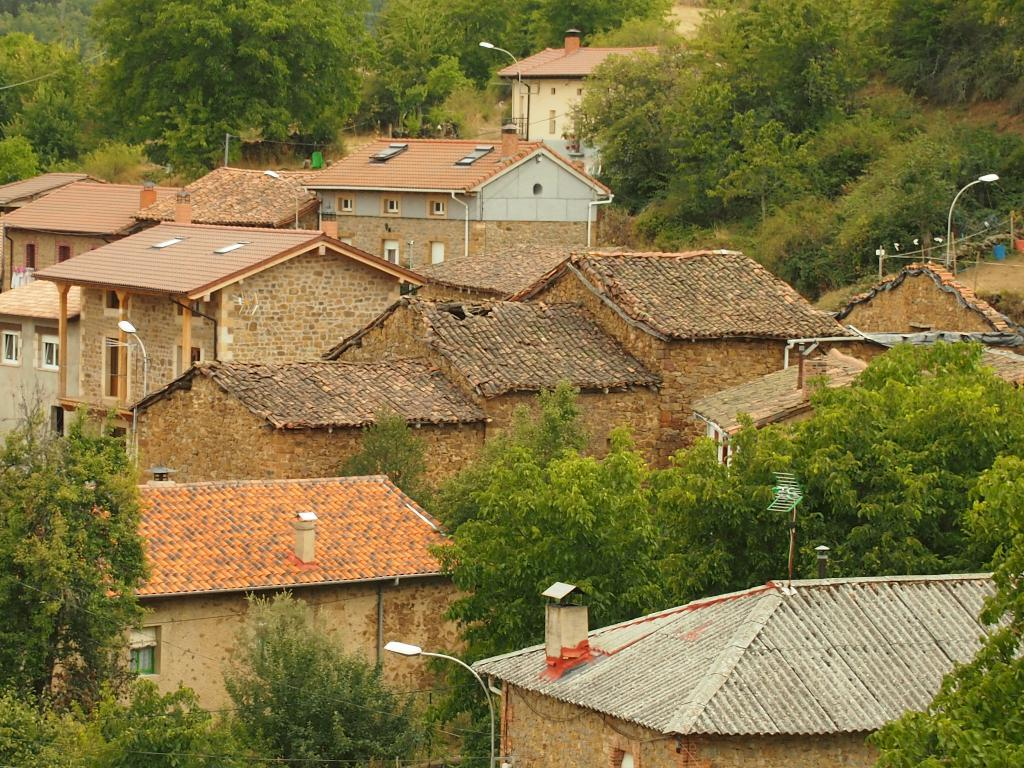What type of structures are located in the middle of the image? There are houses and huts in the image. How are the houses and huts arranged in the image? The houses and huts are in the middle of the image, with trees between them. Can you describe the presence of a light pole in the image? There is a light pole on the right side of the image, among the huts. What type of hair can be seen on the trees in the image? There is no hair present on the trees in the image; they are simply trees with leaves or branches. 